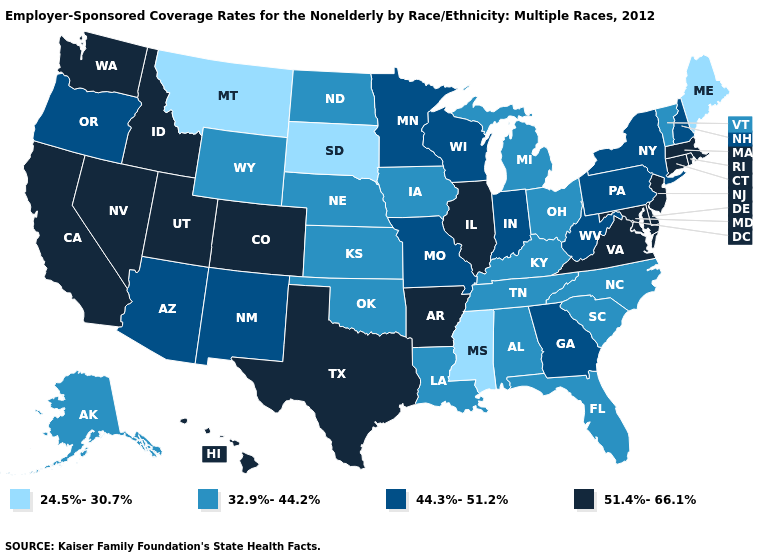Name the states that have a value in the range 51.4%-66.1%?
Give a very brief answer. Arkansas, California, Colorado, Connecticut, Delaware, Hawaii, Idaho, Illinois, Maryland, Massachusetts, Nevada, New Jersey, Rhode Island, Texas, Utah, Virginia, Washington. What is the value of New Hampshire?
Be succinct. 44.3%-51.2%. Does Massachusetts have the same value as Colorado?
Short answer required. Yes. What is the highest value in the Northeast ?
Be succinct. 51.4%-66.1%. Is the legend a continuous bar?
Short answer required. No. Does Utah have a lower value than North Dakota?
Short answer required. No. Among the states that border Virginia , does Maryland have the highest value?
Concise answer only. Yes. Name the states that have a value in the range 44.3%-51.2%?
Quick response, please. Arizona, Georgia, Indiana, Minnesota, Missouri, New Hampshire, New Mexico, New York, Oregon, Pennsylvania, West Virginia, Wisconsin. What is the value of New York?
Give a very brief answer. 44.3%-51.2%. Does Connecticut have the highest value in the USA?
Short answer required. Yes. Does Kansas have the same value as Wisconsin?
Short answer required. No. Name the states that have a value in the range 44.3%-51.2%?
Be succinct. Arizona, Georgia, Indiana, Minnesota, Missouri, New Hampshire, New Mexico, New York, Oregon, Pennsylvania, West Virginia, Wisconsin. Does Vermont have the highest value in the Northeast?
Answer briefly. No. Is the legend a continuous bar?
Quick response, please. No. 